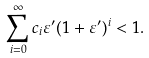<formula> <loc_0><loc_0><loc_500><loc_500>\sum _ { i = 0 } ^ { \infty } c _ { i } \varepsilon ^ { \prime } ( 1 + \varepsilon ^ { \prime } ) ^ { i } < 1 .</formula> 